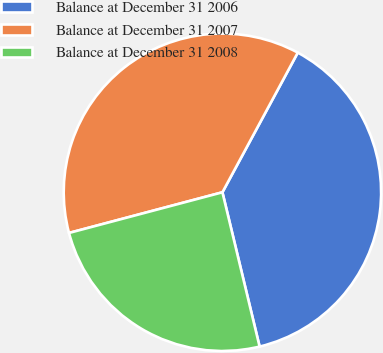<chart> <loc_0><loc_0><loc_500><loc_500><pie_chart><fcel>Balance at December 31 2006<fcel>Balance at December 31 2007<fcel>Balance at December 31 2008<nl><fcel>38.36%<fcel>37.0%<fcel>24.64%<nl></chart> 